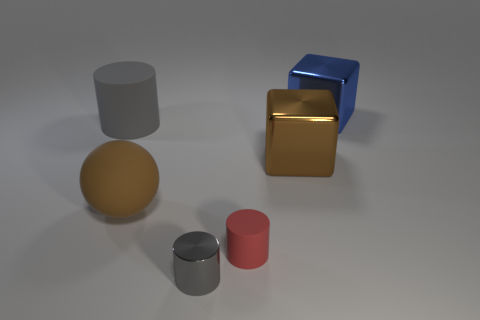Subtract all matte cylinders. How many cylinders are left? 1 Subtract 1 spheres. How many spheres are left? 0 Subtract all yellow blocks. Subtract all brown balls. How many blocks are left? 2 Add 1 big blue things. How many objects exist? 7 Subtract all gray cylinders. How many cylinders are left? 1 Subtract 0 red cubes. How many objects are left? 6 Subtract all cubes. How many objects are left? 4 Subtract all green cylinders. How many blue cubes are left? 1 Subtract all tiny cylinders. Subtract all big red shiny spheres. How many objects are left? 4 Add 1 large brown balls. How many large brown balls are left? 2 